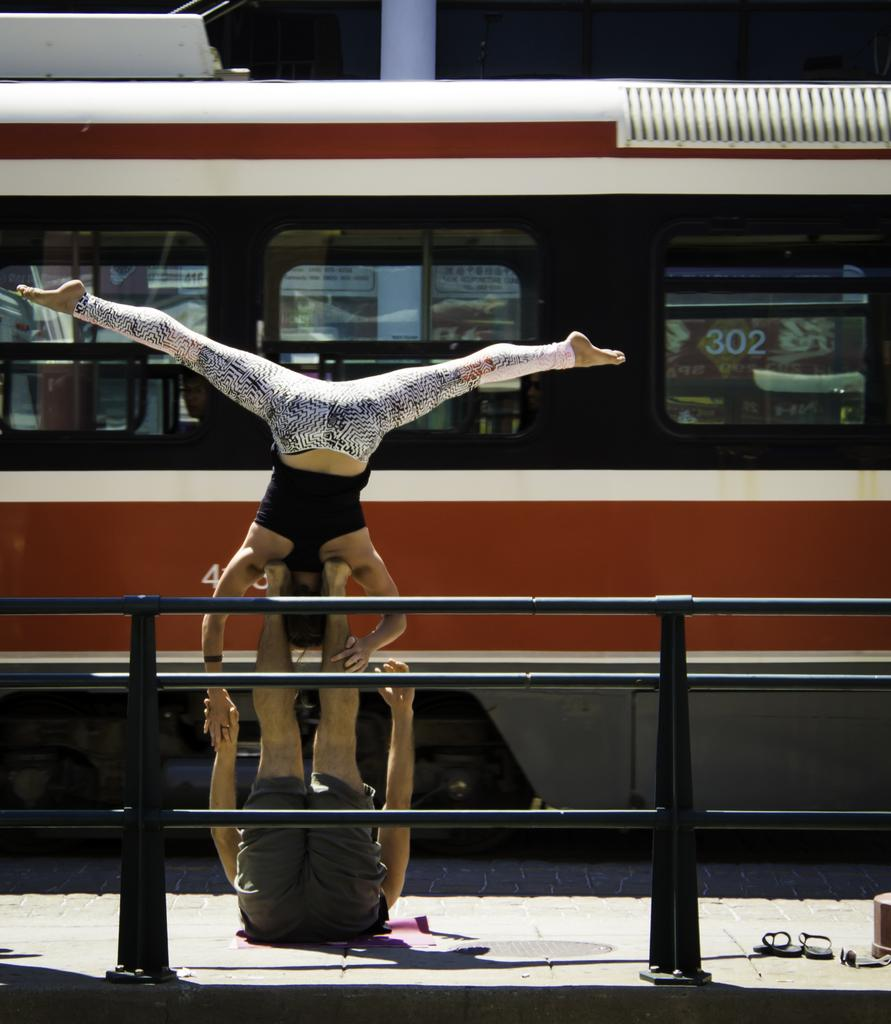Who or what is present in the image? There are people in the image. What are the people doing in the image? The people appear to be performing a stunt. What can be seen in the foreground of the image? There is a boundary in the foreground area of the image. What is visible in the background of the image? There is a bus visible in the background of the image. Can you provide an example of a slave in the image? There is no mention of a slave or any related subject in the image. The image features people performing a stunt, a boundary in the foreground, and a bus in the background. 